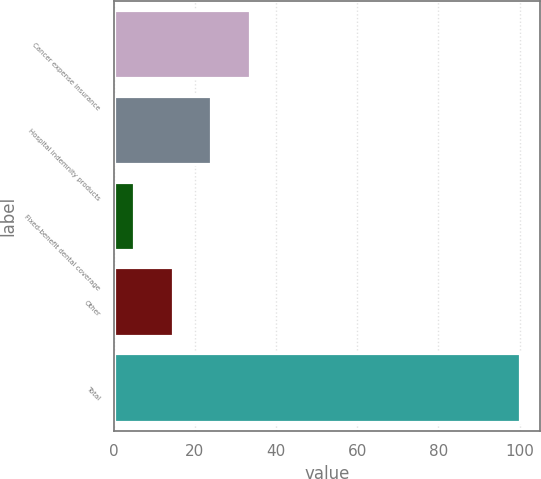Convert chart to OTSL. <chart><loc_0><loc_0><loc_500><loc_500><bar_chart><fcel>Cancer expense insurance<fcel>Hospital indemnity products<fcel>Fixed-benefit dental coverage<fcel>Other<fcel>Total<nl><fcel>33.5<fcel>24<fcel>5<fcel>14.5<fcel>100<nl></chart> 